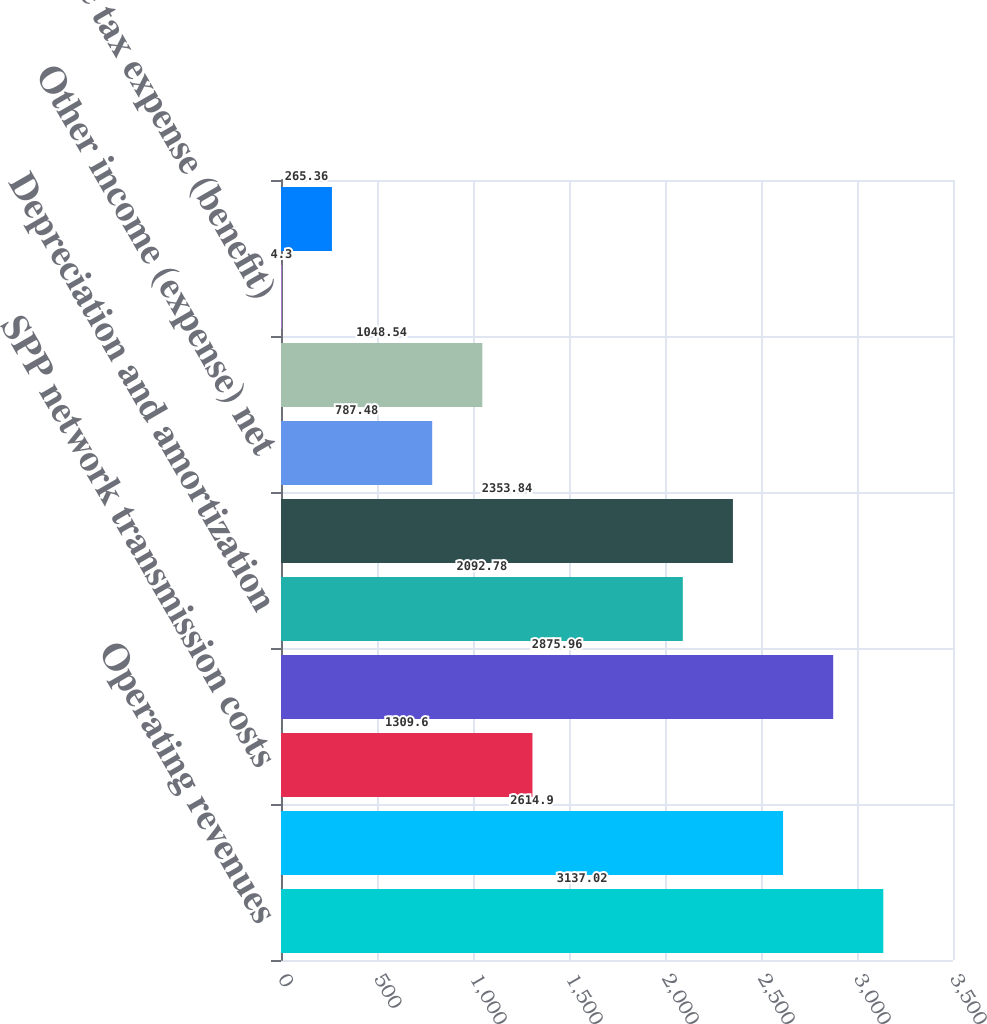Convert chart. <chart><loc_0><loc_0><loc_500><loc_500><bar_chart><fcel>Operating revenues<fcel>Fuel and purchased power<fcel>SPP network transmission costs<fcel>Other operating expenses<fcel>Depreciation and amortization<fcel>Income from operations<fcel>Other income (expense) net<fcel>Interest expense<fcel>Income tax expense (benefit)<fcel>Equity in earnings of equity<nl><fcel>3137.02<fcel>2614.9<fcel>1309.6<fcel>2875.96<fcel>2092.78<fcel>2353.84<fcel>787.48<fcel>1048.54<fcel>4.3<fcel>265.36<nl></chart> 